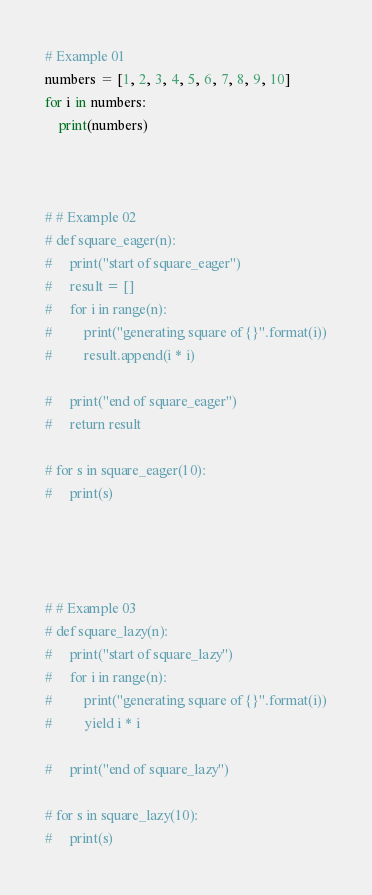Convert code to text. <code><loc_0><loc_0><loc_500><loc_500><_Python_># Example 01
numbers = [1, 2, 3, 4, 5, 6, 7, 8, 9, 10]
for i in numbers:
    print(numbers)



# # Example 02
# def square_eager(n):
#     print("start of square_eager")
#     result = []
#     for i in range(n):
#         print("generating square of {}".format(i))
#         result.append(i * i)

#     print("end of square_eager")
#     return result

# for s in square_eager(10):
#     print(s)




# # Example 03
# def square_lazy(n):
#     print("start of square_lazy")
#     for i in range(n):
#         print("generating square of {}".format(i))
#         yield i * i

#     print("end of square_lazy")

# for s in square_lazy(10):
#     print(s)
</code> 